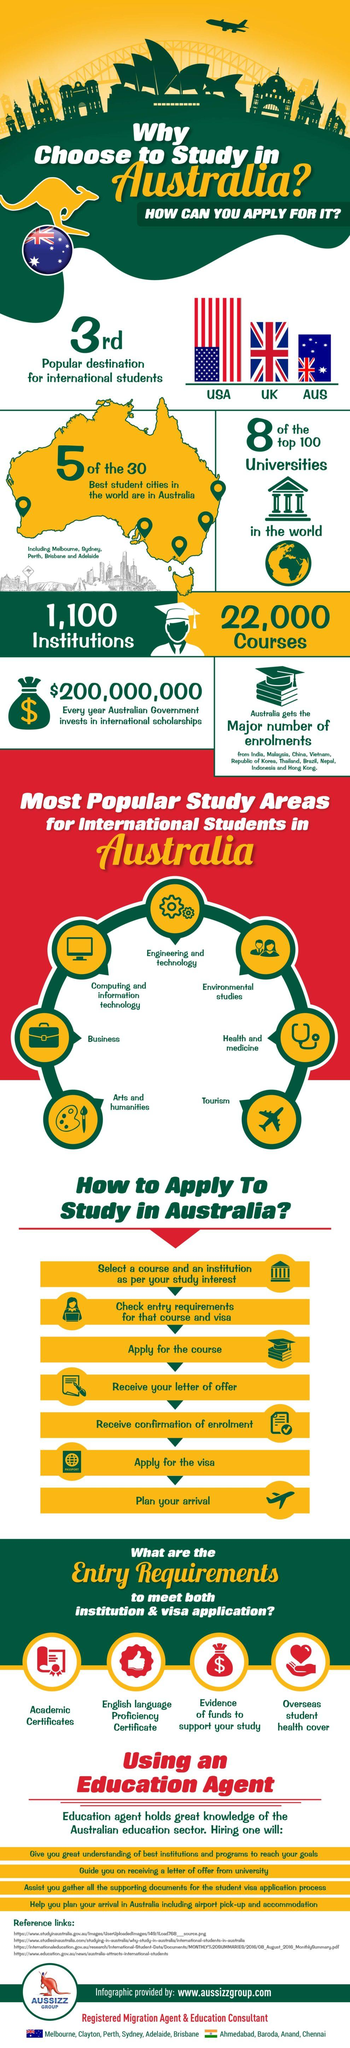Specify some key components in this picture. There are 7 steps required to apply to study in Australia. The United States is the most popular destination for international students. The number of institutions is approximately 1,100. The UK is the second most popular destination for international students. There are seven popular study areas for international students in Australia. 